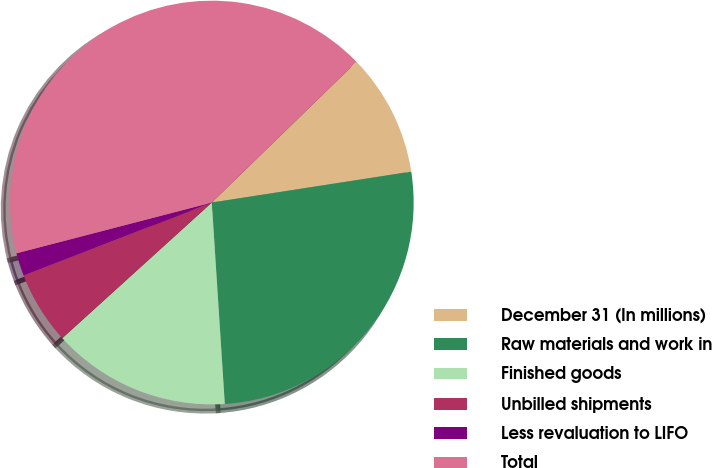<chart> <loc_0><loc_0><loc_500><loc_500><pie_chart><fcel>December 31 (In millions)<fcel>Raw materials and work in<fcel>Finished goods<fcel>Unbilled shipments<fcel>Less revaluation to LIFO<fcel>Total<nl><fcel>9.83%<fcel>26.42%<fcel>14.3%<fcel>5.84%<fcel>1.84%<fcel>41.77%<nl></chart> 